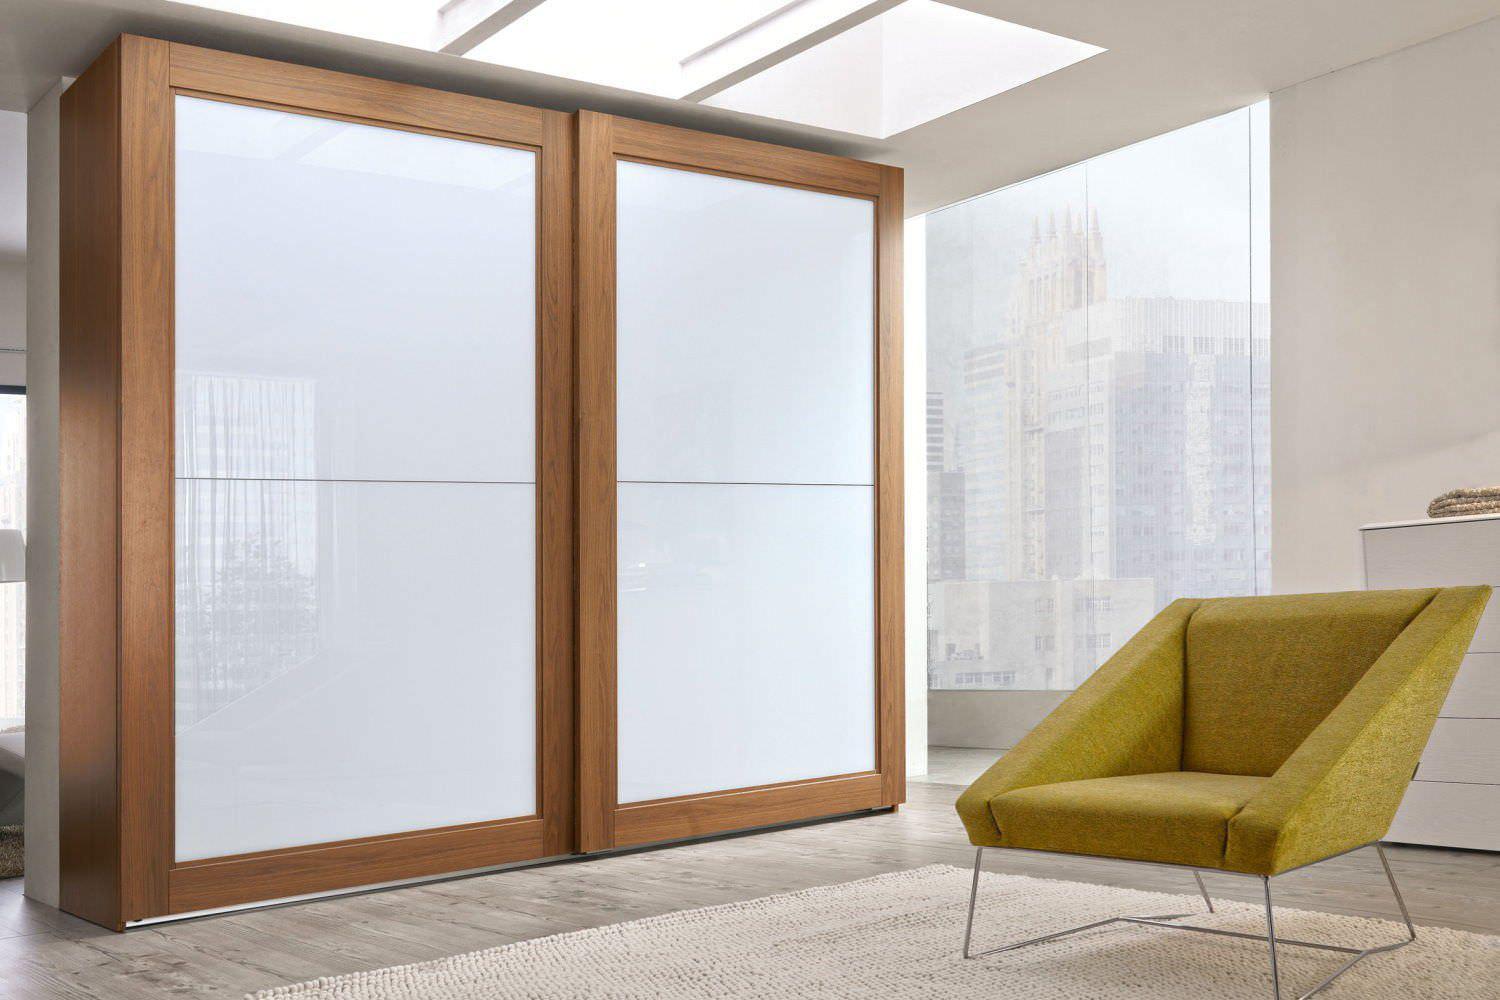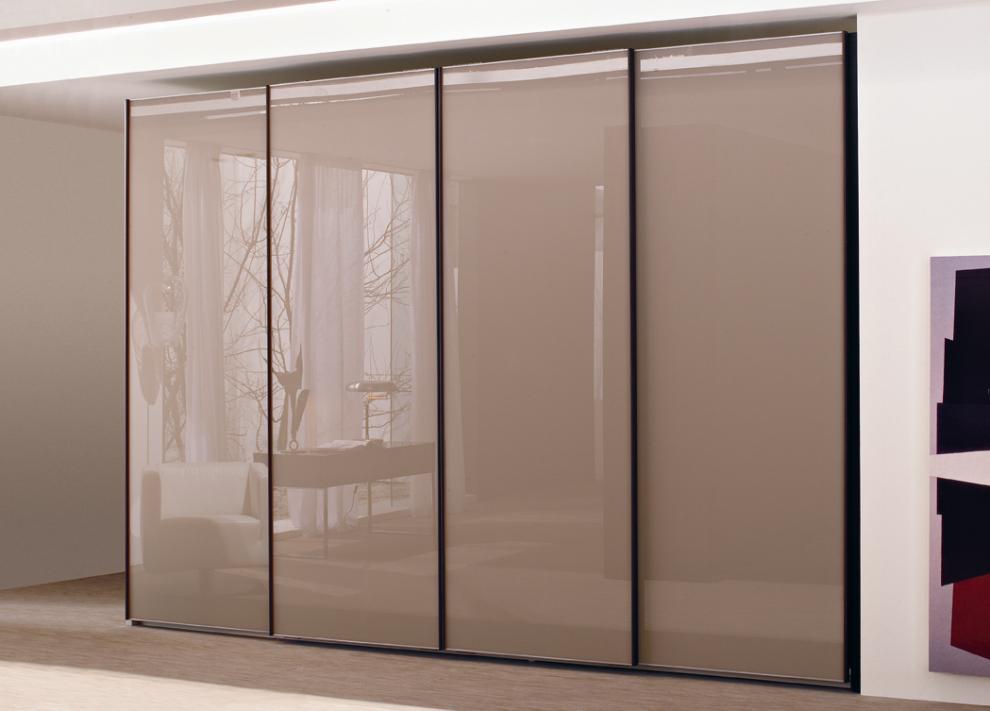The first image is the image on the left, the second image is the image on the right. Assess this claim about the two images: "The left and right image contains the same number of closed closet doors.". Correct or not? Answer yes or no. No. The first image is the image on the left, the second image is the image on the right. Given the left and right images, does the statement "The right image shows at least three earth-tone sliding doors with no embellishments." hold true? Answer yes or no. Yes. 